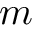<formula> <loc_0><loc_0><loc_500><loc_500>m</formula> 